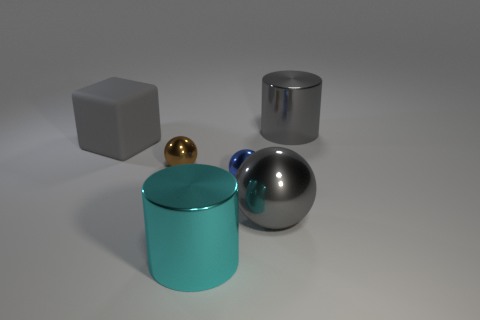What lighting conditions are present in the scene with these objects? The lighting in the scene is soft and diffused with no harsh shadows, suggesting an environment with ambient light sources, possibly simulating indirect daylight or a room with soft artificial lighting. 